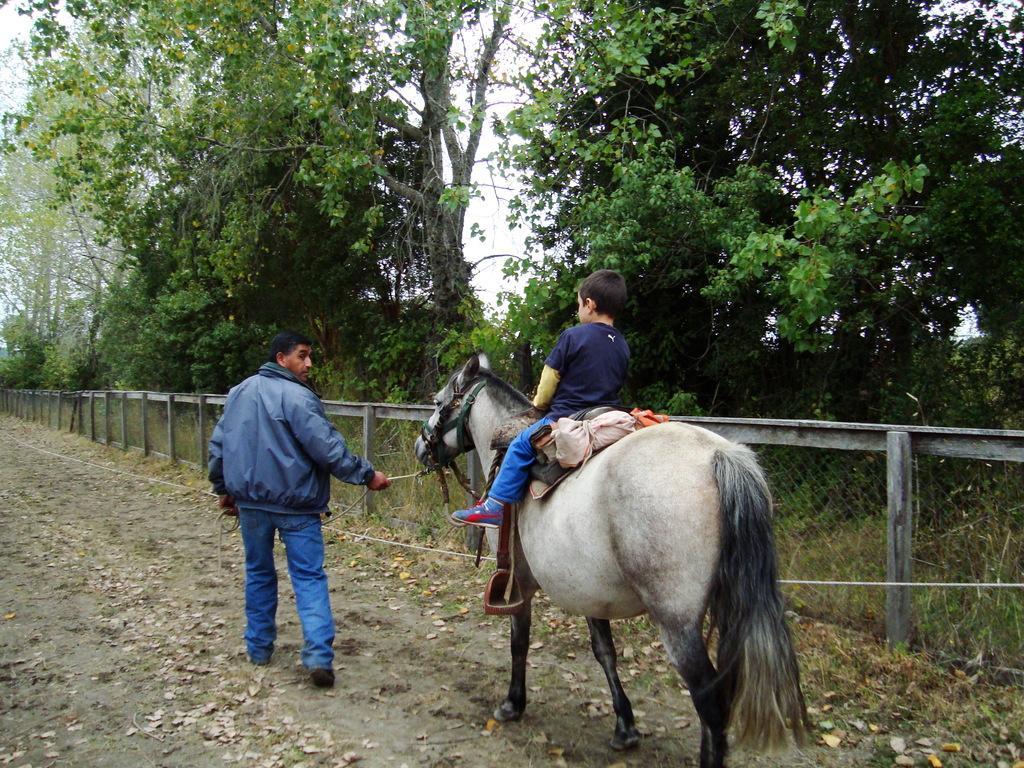Describe this image in one or two sentences. This man in blue jacket is standing and this boy is sitting on a horse. This are trees. This is a fence. 